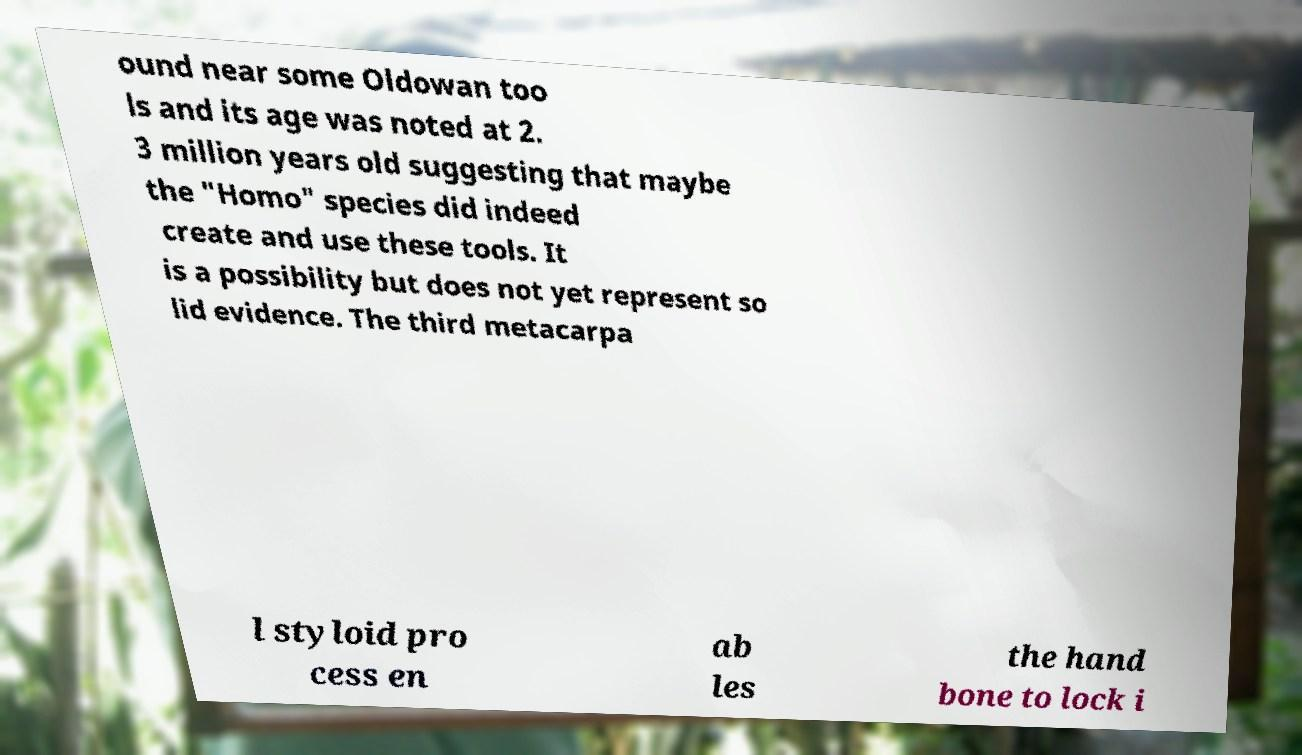Could you extract and type out the text from this image? ound near some Oldowan too ls and its age was noted at 2. 3 million years old suggesting that maybe the "Homo" species did indeed create and use these tools. It is a possibility but does not yet represent so lid evidence. The third metacarpa l styloid pro cess en ab les the hand bone to lock i 